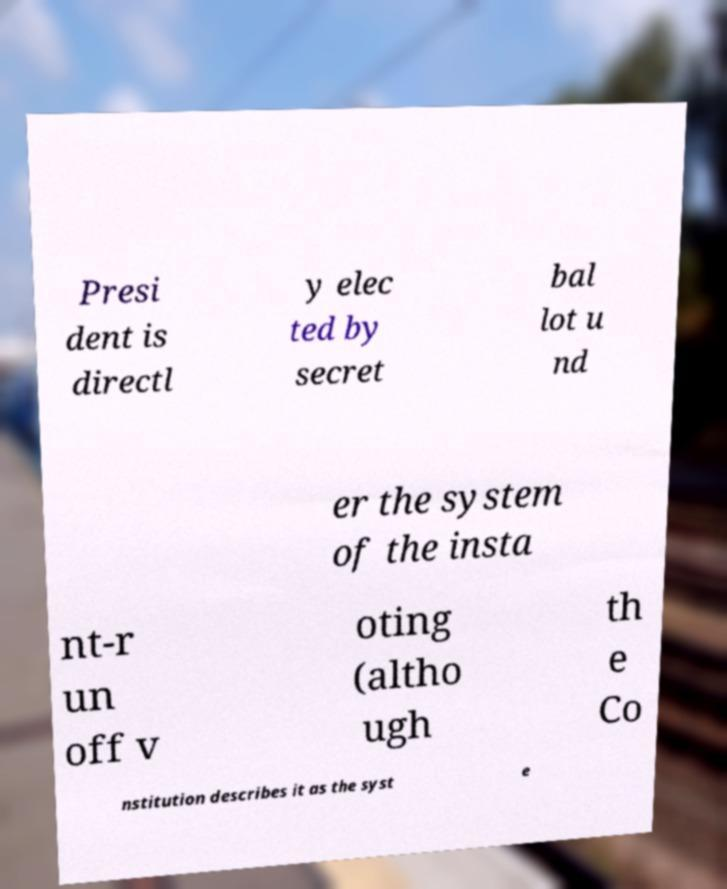Can you accurately transcribe the text from the provided image for me? Presi dent is directl y elec ted by secret bal lot u nd er the system of the insta nt-r un off v oting (altho ugh th e Co nstitution describes it as the syst e 